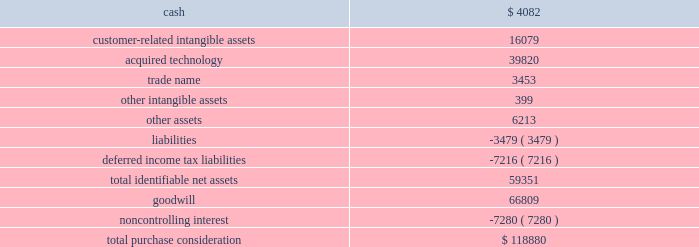Acquisition date ) .
Realex is a leading european online payment gateway technology provider .
This acquisition furthered our strategy to provide omnichannel solutions that combine gateway services , payment service provisioning and payment technology services across europe .
This transaction was accounted for as a business combination .
We recorded the assets acquired , liabilities assumed and noncontrolling interest at their estimated fair values as of the acquisition date .
On october 5 , 2015 , we paid 20ac6.7 million ( $ 7.5 million equivalent as of october 5 , 2015 ) to acquire the remaining shares of realex , after which we own 100% ( 100 % ) of the outstanding shares .
The estimated acquisition date fair values of the assets acquired , liabilities assumed and the noncontrolling interest , including a reconciliation to the total purchase consideration , are as follows ( in thousands ) : .
Goodwill of $ 66.8 million arising from the acquisition , included in the europe segment , was attributable to expected growth opportunities in europe , potential synergies from combining our existing business with gateway services and payment service provisioning in certain markets and an assembled workforce to support the newly acquired technology .
Goodwill associated with this acquisition is not deductible for income tax purposes .
The customer-related intangible assets have an estimated amortization period of 16 years .
The acquired technology has an estimated amortization of 10 years .
The trade name has an estimated amortization period of 7 years .
Ezidebit on october 10 , 2014 , we completed the acquisition of 100% ( 100 % ) of the outstanding stock of ezi holdings pty ltd ( 201cezidebit 201d ) for aud302.6 million in cash ( $ 266.0 million equivalent as of the acquisition date ) .
This acquisition was funded by a combination of cash on hand and borrowings on our revolving credit facility .
Ezidebit is a leading integrated payments company focused on recurring payments verticals in australia and new zealand .
The acquisition of ezidebit further enhanced our existing integrated solutions offerings .
This transaction was accounted for as a business combination .
We recorded the assets acquired and liabilities assumed at their estimated fair values as of the acquisition date .
76 2013 global payments inc .
| 2017 form 10-k annual report .
What percentage of the total purchase consideration did the trade name represent? 
Computations: (3453 / 118880)
Answer: 0.02905. 